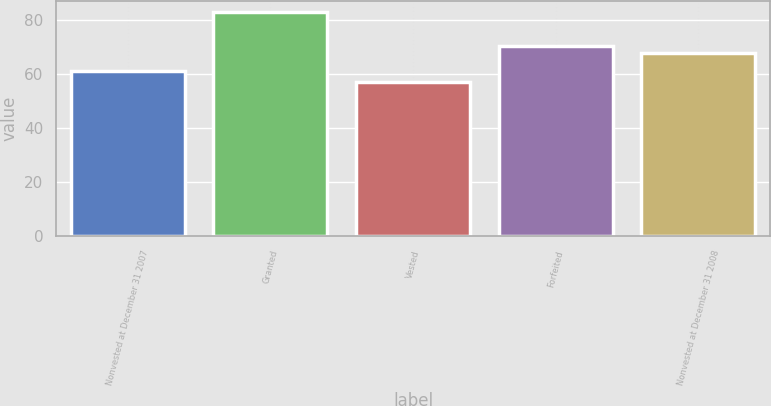<chart> <loc_0><loc_0><loc_500><loc_500><bar_chart><fcel>Nonvested at December 31 2007<fcel>Granted<fcel>Vested<fcel>Forfeited<fcel>Nonvested at December 31 2008<nl><fcel>61.3<fcel>83.05<fcel>57.06<fcel>70.55<fcel>67.95<nl></chart> 